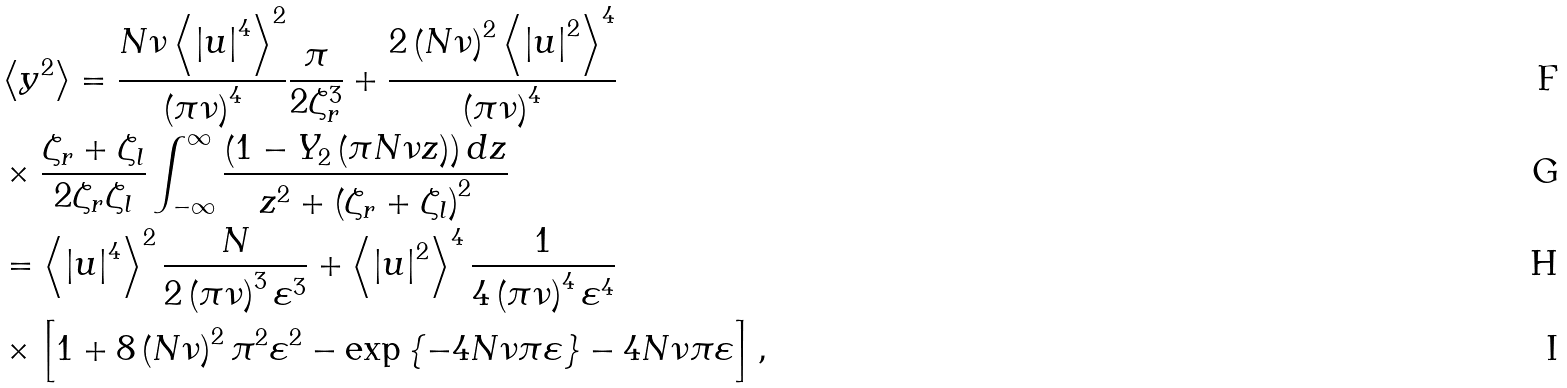<formula> <loc_0><loc_0><loc_500><loc_500>& \left \langle y ^ { 2 } \right \rangle = \frac { N \nu \left \langle \left | u \right | ^ { 4 } \right \rangle ^ { 2 } } { \left ( \pi \nu \right ) ^ { 4 } } \frac { \pi } { 2 \zeta _ { r } ^ { 3 } } + \frac { 2 \left ( N \nu \right ) ^ { 2 } \left \langle \left | u \right | ^ { 2 } \right \rangle ^ { 4 } } { \left ( \pi \nu \right ) ^ { 4 } } \\ & \times \frac { \zeta _ { r } + \zeta _ { l } } { 2 \zeta _ { r } \zeta _ { l } } \int _ { - \infty } ^ { \infty } \frac { \left ( 1 - Y _ { 2 } \left ( \pi N \nu z \right ) \right ) d z } { z ^ { 2 } + \left ( \zeta _ { r } + \zeta _ { l } \right ) ^ { 2 } } \\ & = \left \langle \left | u \right | ^ { 4 } \right \rangle ^ { 2 } \frac { N } { 2 \left ( \pi \nu \right ) ^ { 3 } \varepsilon ^ { 3 } } + \left \langle \left | u \right | ^ { 2 } \right \rangle ^ { 4 } \frac { 1 } { 4 \left ( \pi \nu \right ) ^ { 4 } \varepsilon ^ { 4 } } \\ & \times \left [ 1 + 8 \left ( N \nu \right ) ^ { 2 } \pi ^ { 2 } \varepsilon ^ { 2 } - \exp \left \{ - 4 N \nu \pi \varepsilon \right \} - 4 N \nu \pi \varepsilon \right ] ,</formula> 